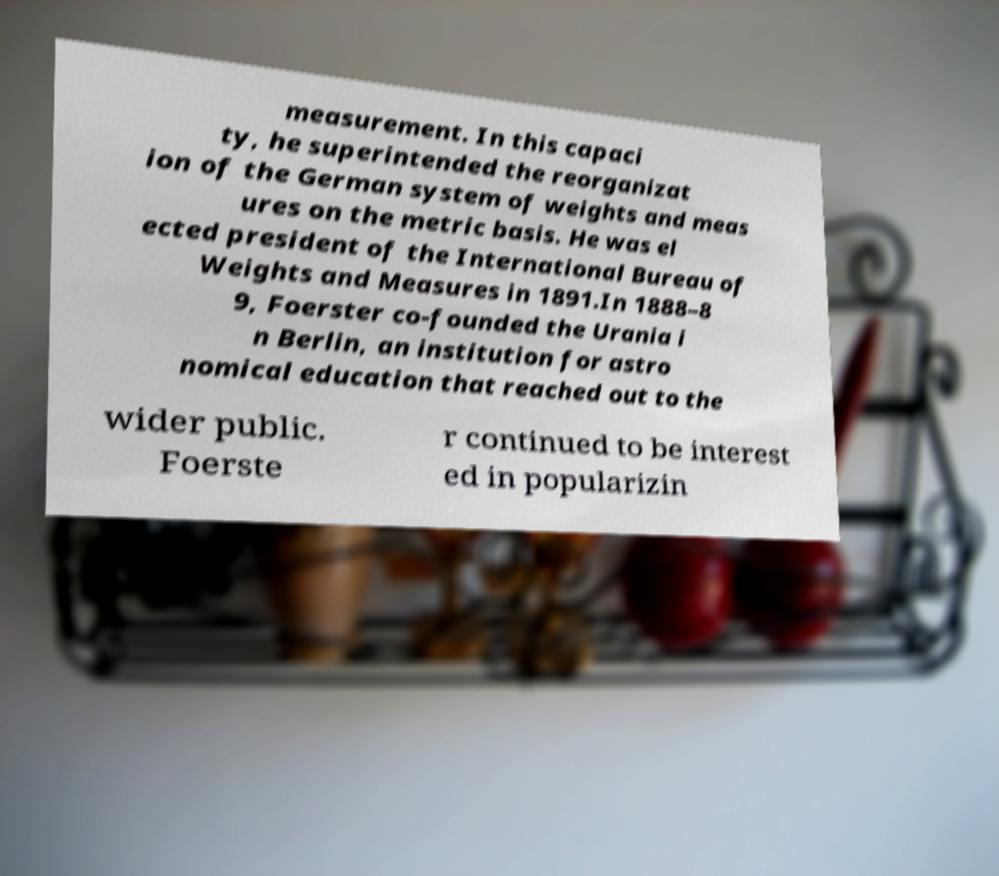Please read and relay the text visible in this image. What does it say? measurement. In this capaci ty, he superintended the reorganizat ion of the German system of weights and meas ures on the metric basis. He was el ected president of the International Bureau of Weights and Measures in 1891.In 1888–8 9, Foerster co-founded the Urania i n Berlin, an institution for astro nomical education that reached out to the wider public. Foerste r continued to be interest ed in popularizin 